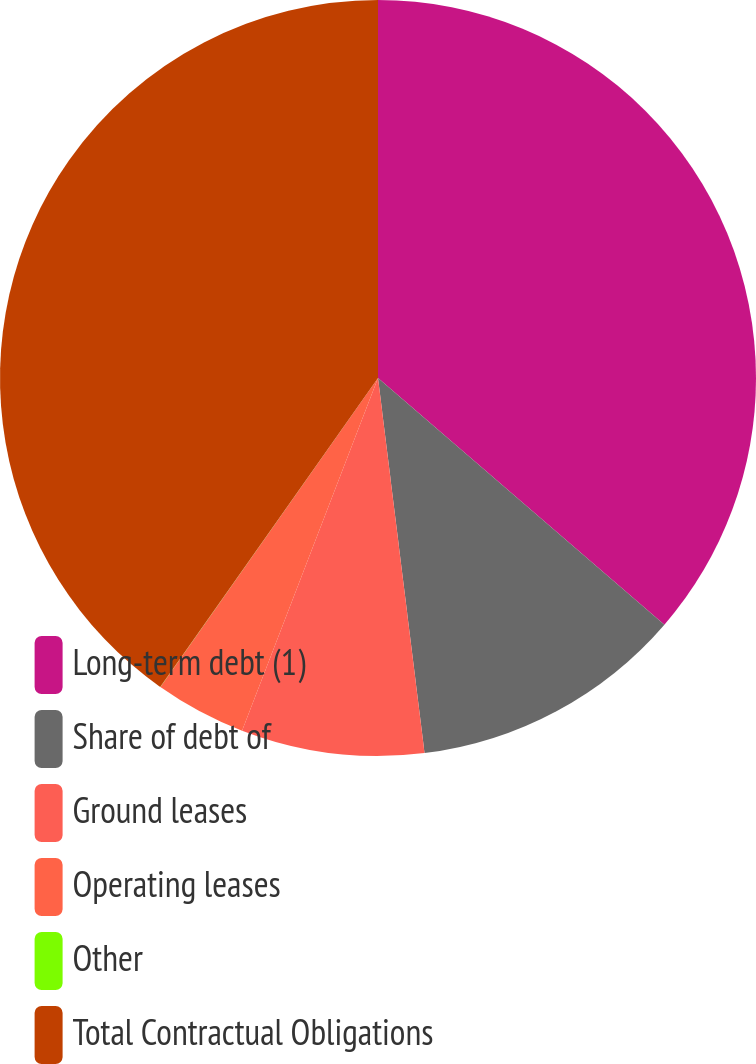Convert chart. <chart><loc_0><loc_0><loc_500><loc_500><pie_chart><fcel>Long-term debt (1)<fcel>Share of debt of<fcel>Ground leases<fcel>Operating leases<fcel>Other<fcel>Total Contractual Obligations<nl><fcel>36.32%<fcel>11.72%<fcel>7.82%<fcel>3.91%<fcel>0.01%<fcel>40.23%<nl></chart> 